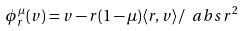Convert formula to latex. <formula><loc_0><loc_0><loc_500><loc_500>\phi _ { r } ^ { \mu } ( v ) = v - r ( 1 - \mu ) \langle r , v \rangle / \ a b s { r } ^ { 2 }</formula> 